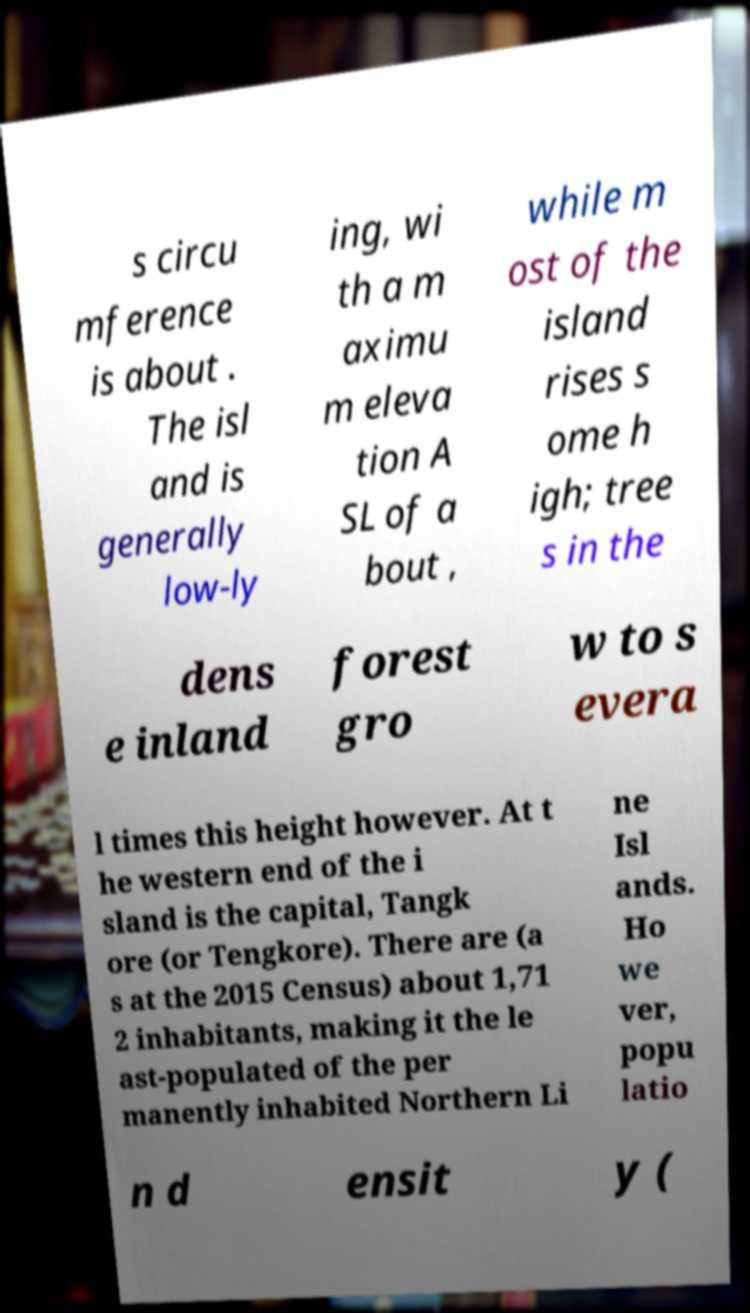Please identify and transcribe the text found in this image. s circu mference is about . The isl and is generally low-ly ing, wi th a m aximu m eleva tion A SL of a bout , while m ost of the island rises s ome h igh; tree s in the dens e inland forest gro w to s evera l times this height however. At t he western end of the i sland is the capital, Tangk ore (or Tengkore). There are (a s at the 2015 Census) about 1,71 2 inhabitants, making it the le ast-populated of the per manently inhabited Northern Li ne Isl ands. Ho we ver, popu latio n d ensit y ( 